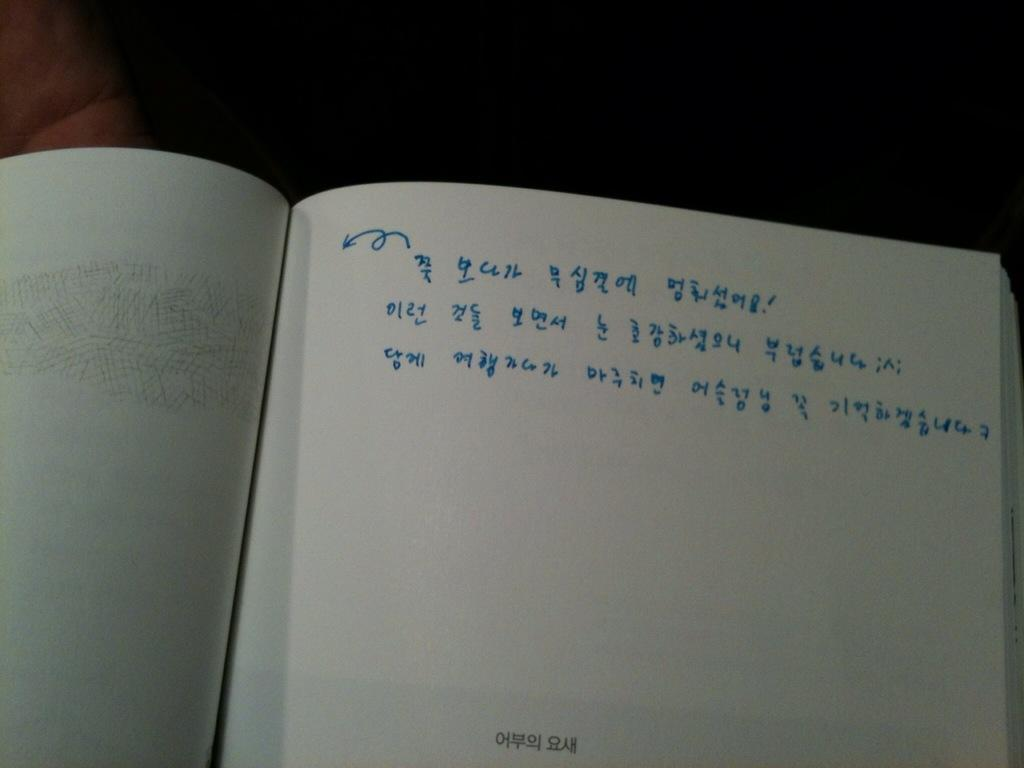<image>
Share a concise interpretation of the image provided. A book page that has blue writing in a different language. 